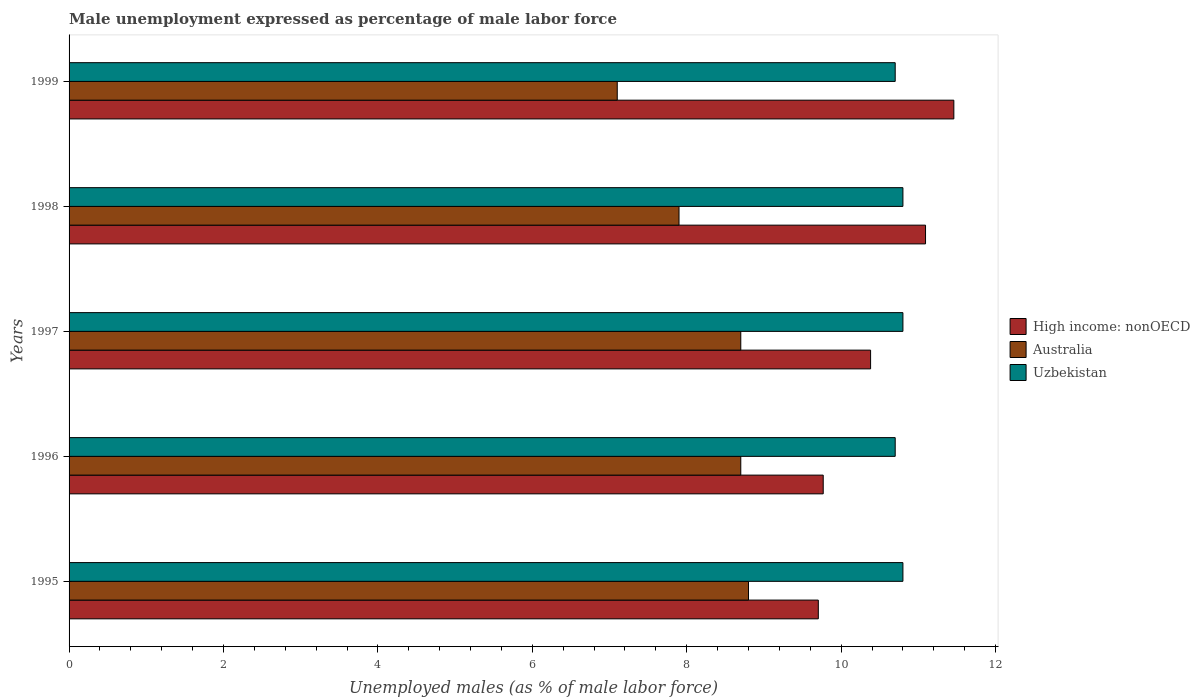How many different coloured bars are there?
Your answer should be compact. 3. How many groups of bars are there?
Offer a very short reply. 5. Are the number of bars per tick equal to the number of legend labels?
Your response must be concise. Yes. Are the number of bars on each tick of the Y-axis equal?
Offer a terse response. Yes. How many bars are there on the 3rd tick from the bottom?
Give a very brief answer. 3. In how many cases, is the number of bars for a given year not equal to the number of legend labels?
Your answer should be compact. 0. What is the unemployment in males in in Australia in 1999?
Offer a terse response. 7.1. Across all years, what is the maximum unemployment in males in in Uzbekistan?
Offer a very short reply. 10.8. Across all years, what is the minimum unemployment in males in in Uzbekistan?
Keep it short and to the point. 10.7. In which year was the unemployment in males in in Uzbekistan maximum?
Keep it short and to the point. 1995. In which year was the unemployment in males in in Uzbekistan minimum?
Offer a terse response. 1996. What is the total unemployment in males in in Uzbekistan in the graph?
Keep it short and to the point. 53.8. What is the difference between the unemployment in males in in Australia in 1996 and that in 1997?
Make the answer very short. 0. What is the difference between the unemployment in males in in Australia in 1997 and the unemployment in males in in High income: nonOECD in 1999?
Your response must be concise. -2.76. What is the average unemployment in males in in High income: nonOECD per year?
Give a very brief answer. 10.48. In the year 1995, what is the difference between the unemployment in males in in High income: nonOECD and unemployment in males in in Australia?
Your answer should be very brief. 0.9. In how many years, is the unemployment in males in in Australia greater than 6.4 %?
Your response must be concise. 5. What is the ratio of the unemployment in males in in High income: nonOECD in 1995 to that in 1997?
Make the answer very short. 0.93. Is the unemployment in males in in High income: nonOECD in 1995 less than that in 1997?
Give a very brief answer. Yes. Is the difference between the unemployment in males in in High income: nonOECD in 1995 and 1999 greater than the difference between the unemployment in males in in Australia in 1995 and 1999?
Provide a succinct answer. No. What is the difference between the highest and the lowest unemployment in males in in Australia?
Offer a terse response. 1.7. What does the 3rd bar from the top in 1996 represents?
Ensure brevity in your answer.  High income: nonOECD. How many bars are there?
Provide a succinct answer. 15. Are all the bars in the graph horizontal?
Your response must be concise. Yes. How many years are there in the graph?
Your answer should be compact. 5. What is the difference between two consecutive major ticks on the X-axis?
Ensure brevity in your answer.  2. Does the graph contain grids?
Offer a very short reply. No. Where does the legend appear in the graph?
Your answer should be very brief. Center right. How many legend labels are there?
Ensure brevity in your answer.  3. What is the title of the graph?
Make the answer very short. Male unemployment expressed as percentage of male labor force. What is the label or title of the X-axis?
Provide a succinct answer. Unemployed males (as % of male labor force). What is the label or title of the Y-axis?
Your answer should be compact. Years. What is the Unemployed males (as % of male labor force) of High income: nonOECD in 1995?
Provide a short and direct response. 9.7. What is the Unemployed males (as % of male labor force) of Australia in 1995?
Ensure brevity in your answer.  8.8. What is the Unemployed males (as % of male labor force) of Uzbekistan in 1995?
Give a very brief answer. 10.8. What is the Unemployed males (as % of male labor force) in High income: nonOECD in 1996?
Keep it short and to the point. 9.77. What is the Unemployed males (as % of male labor force) in Australia in 1996?
Your answer should be compact. 8.7. What is the Unemployed males (as % of male labor force) in Uzbekistan in 1996?
Offer a very short reply. 10.7. What is the Unemployed males (as % of male labor force) of High income: nonOECD in 1997?
Your answer should be compact. 10.38. What is the Unemployed males (as % of male labor force) of Australia in 1997?
Offer a very short reply. 8.7. What is the Unemployed males (as % of male labor force) of Uzbekistan in 1997?
Keep it short and to the point. 10.8. What is the Unemployed males (as % of male labor force) of High income: nonOECD in 1998?
Your answer should be compact. 11.09. What is the Unemployed males (as % of male labor force) of Australia in 1998?
Your answer should be compact. 7.9. What is the Unemployed males (as % of male labor force) of Uzbekistan in 1998?
Make the answer very short. 10.8. What is the Unemployed males (as % of male labor force) of High income: nonOECD in 1999?
Give a very brief answer. 11.46. What is the Unemployed males (as % of male labor force) in Australia in 1999?
Make the answer very short. 7.1. What is the Unemployed males (as % of male labor force) of Uzbekistan in 1999?
Ensure brevity in your answer.  10.7. Across all years, what is the maximum Unemployed males (as % of male labor force) in High income: nonOECD?
Ensure brevity in your answer.  11.46. Across all years, what is the maximum Unemployed males (as % of male labor force) of Australia?
Provide a short and direct response. 8.8. Across all years, what is the maximum Unemployed males (as % of male labor force) of Uzbekistan?
Your answer should be compact. 10.8. Across all years, what is the minimum Unemployed males (as % of male labor force) of High income: nonOECD?
Make the answer very short. 9.7. Across all years, what is the minimum Unemployed males (as % of male labor force) of Australia?
Your response must be concise. 7.1. Across all years, what is the minimum Unemployed males (as % of male labor force) of Uzbekistan?
Keep it short and to the point. 10.7. What is the total Unemployed males (as % of male labor force) of High income: nonOECD in the graph?
Make the answer very short. 52.41. What is the total Unemployed males (as % of male labor force) of Australia in the graph?
Your answer should be compact. 41.2. What is the total Unemployed males (as % of male labor force) of Uzbekistan in the graph?
Your answer should be very brief. 53.8. What is the difference between the Unemployed males (as % of male labor force) in High income: nonOECD in 1995 and that in 1996?
Make the answer very short. -0.06. What is the difference between the Unemployed males (as % of male labor force) of Uzbekistan in 1995 and that in 1996?
Offer a terse response. 0.1. What is the difference between the Unemployed males (as % of male labor force) in High income: nonOECD in 1995 and that in 1997?
Your answer should be compact. -0.68. What is the difference between the Unemployed males (as % of male labor force) of High income: nonOECD in 1995 and that in 1998?
Keep it short and to the point. -1.39. What is the difference between the Unemployed males (as % of male labor force) of Australia in 1995 and that in 1998?
Your response must be concise. 0.9. What is the difference between the Unemployed males (as % of male labor force) of Uzbekistan in 1995 and that in 1998?
Your answer should be compact. 0. What is the difference between the Unemployed males (as % of male labor force) in High income: nonOECD in 1995 and that in 1999?
Make the answer very short. -1.76. What is the difference between the Unemployed males (as % of male labor force) in High income: nonOECD in 1996 and that in 1997?
Give a very brief answer. -0.61. What is the difference between the Unemployed males (as % of male labor force) of Uzbekistan in 1996 and that in 1997?
Provide a short and direct response. -0.1. What is the difference between the Unemployed males (as % of male labor force) of High income: nonOECD in 1996 and that in 1998?
Your answer should be compact. -1.33. What is the difference between the Unemployed males (as % of male labor force) of Uzbekistan in 1996 and that in 1998?
Provide a succinct answer. -0.1. What is the difference between the Unemployed males (as % of male labor force) in High income: nonOECD in 1996 and that in 1999?
Keep it short and to the point. -1.69. What is the difference between the Unemployed males (as % of male labor force) of High income: nonOECD in 1997 and that in 1998?
Give a very brief answer. -0.71. What is the difference between the Unemployed males (as % of male labor force) of High income: nonOECD in 1997 and that in 1999?
Offer a terse response. -1.08. What is the difference between the Unemployed males (as % of male labor force) of Australia in 1997 and that in 1999?
Keep it short and to the point. 1.6. What is the difference between the Unemployed males (as % of male labor force) in High income: nonOECD in 1998 and that in 1999?
Offer a very short reply. -0.37. What is the difference between the Unemployed males (as % of male labor force) in Australia in 1998 and that in 1999?
Offer a very short reply. 0.8. What is the difference between the Unemployed males (as % of male labor force) of Uzbekistan in 1998 and that in 1999?
Offer a very short reply. 0.1. What is the difference between the Unemployed males (as % of male labor force) in High income: nonOECD in 1995 and the Unemployed males (as % of male labor force) in Australia in 1996?
Your response must be concise. 1. What is the difference between the Unemployed males (as % of male labor force) of High income: nonOECD in 1995 and the Unemployed males (as % of male labor force) of Uzbekistan in 1996?
Your answer should be compact. -1. What is the difference between the Unemployed males (as % of male labor force) of High income: nonOECD in 1995 and the Unemployed males (as % of male labor force) of Uzbekistan in 1997?
Your answer should be very brief. -1.1. What is the difference between the Unemployed males (as % of male labor force) in Australia in 1995 and the Unemployed males (as % of male labor force) in Uzbekistan in 1997?
Offer a terse response. -2. What is the difference between the Unemployed males (as % of male labor force) in High income: nonOECD in 1995 and the Unemployed males (as % of male labor force) in Australia in 1998?
Offer a terse response. 1.8. What is the difference between the Unemployed males (as % of male labor force) in High income: nonOECD in 1995 and the Unemployed males (as % of male labor force) in Uzbekistan in 1998?
Ensure brevity in your answer.  -1.1. What is the difference between the Unemployed males (as % of male labor force) of Australia in 1995 and the Unemployed males (as % of male labor force) of Uzbekistan in 1998?
Offer a very short reply. -2. What is the difference between the Unemployed males (as % of male labor force) in High income: nonOECD in 1995 and the Unemployed males (as % of male labor force) in Australia in 1999?
Offer a very short reply. 2.6. What is the difference between the Unemployed males (as % of male labor force) in High income: nonOECD in 1995 and the Unemployed males (as % of male labor force) in Uzbekistan in 1999?
Give a very brief answer. -1. What is the difference between the Unemployed males (as % of male labor force) of Australia in 1995 and the Unemployed males (as % of male labor force) of Uzbekistan in 1999?
Your response must be concise. -1.9. What is the difference between the Unemployed males (as % of male labor force) in High income: nonOECD in 1996 and the Unemployed males (as % of male labor force) in Australia in 1997?
Offer a terse response. 1.07. What is the difference between the Unemployed males (as % of male labor force) in High income: nonOECD in 1996 and the Unemployed males (as % of male labor force) in Uzbekistan in 1997?
Make the answer very short. -1.03. What is the difference between the Unemployed males (as % of male labor force) of Australia in 1996 and the Unemployed males (as % of male labor force) of Uzbekistan in 1997?
Offer a very short reply. -2.1. What is the difference between the Unemployed males (as % of male labor force) of High income: nonOECD in 1996 and the Unemployed males (as % of male labor force) of Australia in 1998?
Provide a succinct answer. 1.87. What is the difference between the Unemployed males (as % of male labor force) in High income: nonOECD in 1996 and the Unemployed males (as % of male labor force) in Uzbekistan in 1998?
Keep it short and to the point. -1.03. What is the difference between the Unemployed males (as % of male labor force) of Australia in 1996 and the Unemployed males (as % of male labor force) of Uzbekistan in 1998?
Your answer should be very brief. -2.1. What is the difference between the Unemployed males (as % of male labor force) in High income: nonOECD in 1996 and the Unemployed males (as % of male labor force) in Australia in 1999?
Your answer should be very brief. 2.67. What is the difference between the Unemployed males (as % of male labor force) of High income: nonOECD in 1996 and the Unemployed males (as % of male labor force) of Uzbekistan in 1999?
Your answer should be very brief. -0.93. What is the difference between the Unemployed males (as % of male labor force) in High income: nonOECD in 1997 and the Unemployed males (as % of male labor force) in Australia in 1998?
Provide a succinct answer. 2.48. What is the difference between the Unemployed males (as % of male labor force) of High income: nonOECD in 1997 and the Unemployed males (as % of male labor force) of Uzbekistan in 1998?
Make the answer very short. -0.42. What is the difference between the Unemployed males (as % of male labor force) in Australia in 1997 and the Unemployed males (as % of male labor force) in Uzbekistan in 1998?
Provide a short and direct response. -2.1. What is the difference between the Unemployed males (as % of male labor force) in High income: nonOECD in 1997 and the Unemployed males (as % of male labor force) in Australia in 1999?
Give a very brief answer. 3.28. What is the difference between the Unemployed males (as % of male labor force) of High income: nonOECD in 1997 and the Unemployed males (as % of male labor force) of Uzbekistan in 1999?
Provide a succinct answer. -0.32. What is the difference between the Unemployed males (as % of male labor force) of Australia in 1997 and the Unemployed males (as % of male labor force) of Uzbekistan in 1999?
Make the answer very short. -2. What is the difference between the Unemployed males (as % of male labor force) of High income: nonOECD in 1998 and the Unemployed males (as % of male labor force) of Australia in 1999?
Offer a very short reply. 3.99. What is the difference between the Unemployed males (as % of male labor force) of High income: nonOECD in 1998 and the Unemployed males (as % of male labor force) of Uzbekistan in 1999?
Your answer should be very brief. 0.39. What is the average Unemployed males (as % of male labor force) of High income: nonOECD per year?
Offer a very short reply. 10.48. What is the average Unemployed males (as % of male labor force) in Australia per year?
Ensure brevity in your answer.  8.24. What is the average Unemployed males (as % of male labor force) in Uzbekistan per year?
Your response must be concise. 10.76. In the year 1995, what is the difference between the Unemployed males (as % of male labor force) of High income: nonOECD and Unemployed males (as % of male labor force) of Australia?
Your response must be concise. 0.9. In the year 1995, what is the difference between the Unemployed males (as % of male labor force) in High income: nonOECD and Unemployed males (as % of male labor force) in Uzbekistan?
Keep it short and to the point. -1.1. In the year 1996, what is the difference between the Unemployed males (as % of male labor force) of High income: nonOECD and Unemployed males (as % of male labor force) of Australia?
Your answer should be very brief. 1.07. In the year 1996, what is the difference between the Unemployed males (as % of male labor force) of High income: nonOECD and Unemployed males (as % of male labor force) of Uzbekistan?
Your response must be concise. -0.93. In the year 1996, what is the difference between the Unemployed males (as % of male labor force) in Australia and Unemployed males (as % of male labor force) in Uzbekistan?
Ensure brevity in your answer.  -2. In the year 1997, what is the difference between the Unemployed males (as % of male labor force) in High income: nonOECD and Unemployed males (as % of male labor force) in Australia?
Your answer should be compact. 1.68. In the year 1997, what is the difference between the Unemployed males (as % of male labor force) in High income: nonOECD and Unemployed males (as % of male labor force) in Uzbekistan?
Your answer should be very brief. -0.42. In the year 1998, what is the difference between the Unemployed males (as % of male labor force) of High income: nonOECD and Unemployed males (as % of male labor force) of Australia?
Provide a short and direct response. 3.19. In the year 1998, what is the difference between the Unemployed males (as % of male labor force) of High income: nonOECD and Unemployed males (as % of male labor force) of Uzbekistan?
Your answer should be very brief. 0.29. In the year 1999, what is the difference between the Unemployed males (as % of male labor force) in High income: nonOECD and Unemployed males (as % of male labor force) in Australia?
Offer a very short reply. 4.36. In the year 1999, what is the difference between the Unemployed males (as % of male labor force) in High income: nonOECD and Unemployed males (as % of male labor force) in Uzbekistan?
Make the answer very short. 0.76. In the year 1999, what is the difference between the Unemployed males (as % of male labor force) of Australia and Unemployed males (as % of male labor force) of Uzbekistan?
Your answer should be compact. -3.6. What is the ratio of the Unemployed males (as % of male labor force) of High income: nonOECD in 1995 to that in 1996?
Offer a very short reply. 0.99. What is the ratio of the Unemployed males (as % of male labor force) of Australia in 1995 to that in 1996?
Provide a succinct answer. 1.01. What is the ratio of the Unemployed males (as % of male labor force) of Uzbekistan in 1995 to that in 1996?
Make the answer very short. 1.01. What is the ratio of the Unemployed males (as % of male labor force) of High income: nonOECD in 1995 to that in 1997?
Give a very brief answer. 0.93. What is the ratio of the Unemployed males (as % of male labor force) in Australia in 1995 to that in 1997?
Make the answer very short. 1.01. What is the ratio of the Unemployed males (as % of male labor force) of High income: nonOECD in 1995 to that in 1998?
Make the answer very short. 0.87. What is the ratio of the Unemployed males (as % of male labor force) in Australia in 1995 to that in 1998?
Your answer should be very brief. 1.11. What is the ratio of the Unemployed males (as % of male labor force) of Uzbekistan in 1995 to that in 1998?
Your response must be concise. 1. What is the ratio of the Unemployed males (as % of male labor force) of High income: nonOECD in 1995 to that in 1999?
Keep it short and to the point. 0.85. What is the ratio of the Unemployed males (as % of male labor force) of Australia in 1995 to that in 1999?
Make the answer very short. 1.24. What is the ratio of the Unemployed males (as % of male labor force) in Uzbekistan in 1995 to that in 1999?
Provide a short and direct response. 1.01. What is the ratio of the Unemployed males (as % of male labor force) of High income: nonOECD in 1996 to that in 1997?
Your response must be concise. 0.94. What is the ratio of the Unemployed males (as % of male labor force) of Australia in 1996 to that in 1997?
Give a very brief answer. 1. What is the ratio of the Unemployed males (as % of male labor force) in Uzbekistan in 1996 to that in 1997?
Your answer should be compact. 0.99. What is the ratio of the Unemployed males (as % of male labor force) of High income: nonOECD in 1996 to that in 1998?
Make the answer very short. 0.88. What is the ratio of the Unemployed males (as % of male labor force) of Australia in 1996 to that in 1998?
Make the answer very short. 1.1. What is the ratio of the Unemployed males (as % of male labor force) in Uzbekistan in 1996 to that in 1998?
Provide a short and direct response. 0.99. What is the ratio of the Unemployed males (as % of male labor force) of High income: nonOECD in 1996 to that in 1999?
Provide a short and direct response. 0.85. What is the ratio of the Unemployed males (as % of male labor force) of Australia in 1996 to that in 1999?
Give a very brief answer. 1.23. What is the ratio of the Unemployed males (as % of male labor force) in Uzbekistan in 1996 to that in 1999?
Make the answer very short. 1. What is the ratio of the Unemployed males (as % of male labor force) in High income: nonOECD in 1997 to that in 1998?
Your answer should be very brief. 0.94. What is the ratio of the Unemployed males (as % of male labor force) in Australia in 1997 to that in 1998?
Give a very brief answer. 1.1. What is the ratio of the Unemployed males (as % of male labor force) in Uzbekistan in 1997 to that in 1998?
Your answer should be compact. 1. What is the ratio of the Unemployed males (as % of male labor force) of High income: nonOECD in 1997 to that in 1999?
Offer a very short reply. 0.91. What is the ratio of the Unemployed males (as % of male labor force) of Australia in 1997 to that in 1999?
Provide a succinct answer. 1.23. What is the ratio of the Unemployed males (as % of male labor force) of Uzbekistan in 1997 to that in 1999?
Make the answer very short. 1.01. What is the ratio of the Unemployed males (as % of male labor force) in Australia in 1998 to that in 1999?
Your response must be concise. 1.11. What is the ratio of the Unemployed males (as % of male labor force) of Uzbekistan in 1998 to that in 1999?
Give a very brief answer. 1.01. What is the difference between the highest and the second highest Unemployed males (as % of male labor force) in High income: nonOECD?
Provide a short and direct response. 0.37. What is the difference between the highest and the lowest Unemployed males (as % of male labor force) of High income: nonOECD?
Make the answer very short. 1.76. 